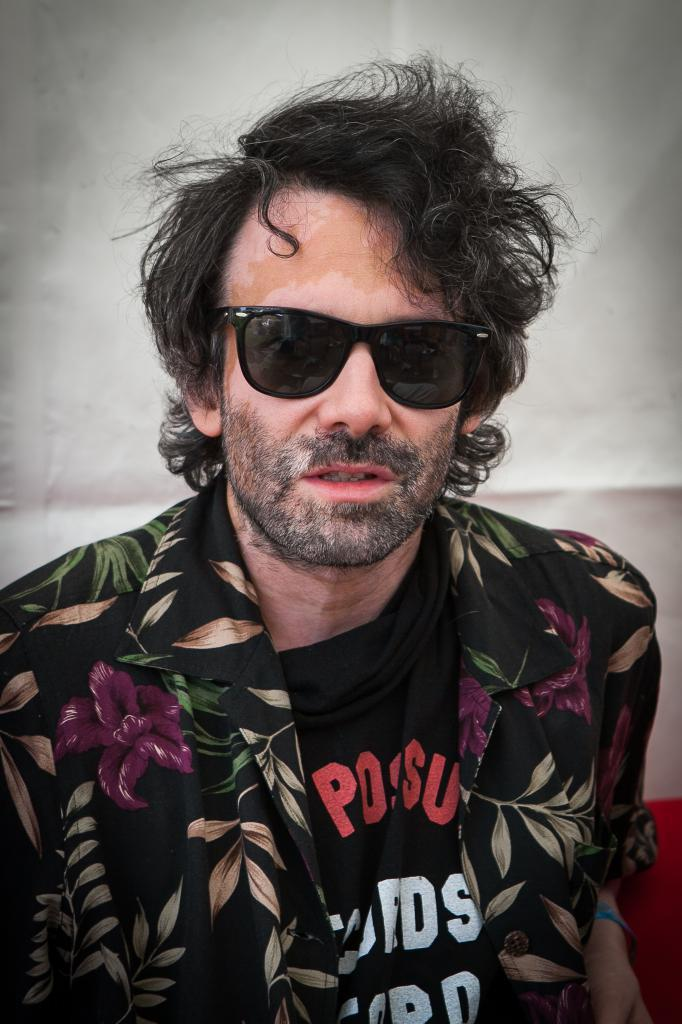What is the main subject of the image? There is a person in the image. What is the person wearing? The person is wearing goggles. What can be seen in the background of the image? There is a wall in the background of the image. What type of machine can be seen in the image? There is no machine present in the image; it features a person wearing goggles with a wall in the background. How many dogs are visible in the image? There are no dogs present in the image. 